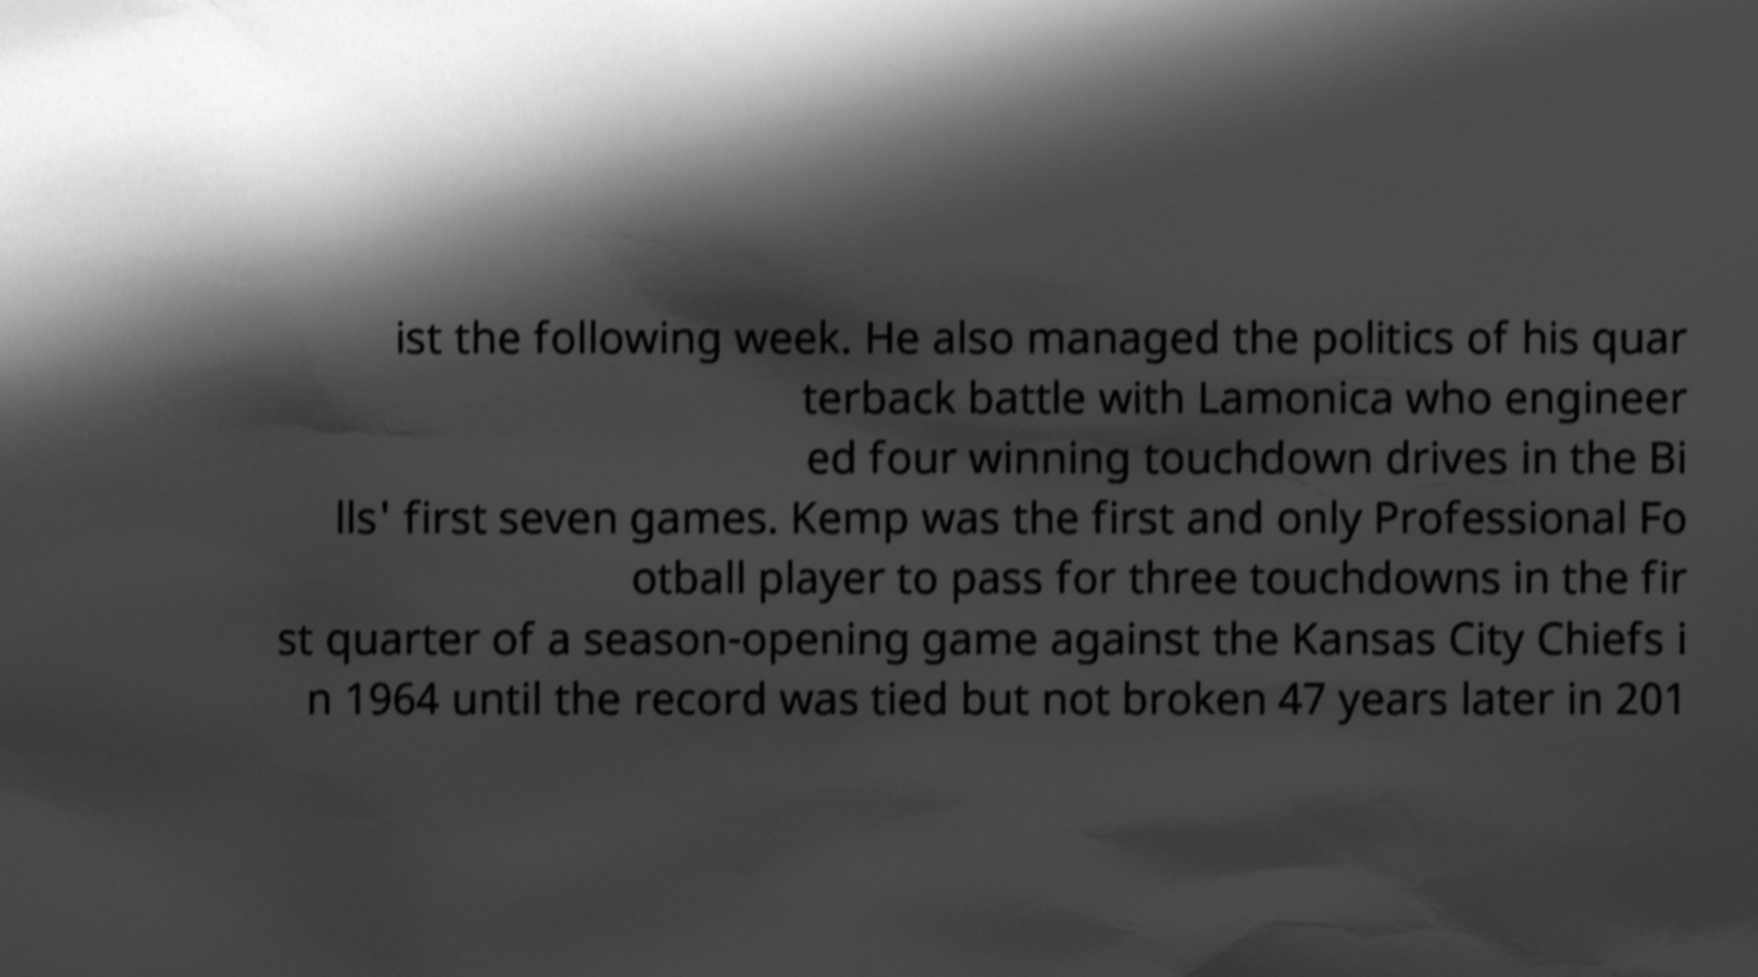Could you assist in decoding the text presented in this image and type it out clearly? ist the following week. He also managed the politics of his quar terback battle with Lamonica who engineer ed four winning touchdown drives in the Bi lls' first seven games. Kemp was the first and only Professional Fo otball player to pass for three touchdowns in the fir st quarter of a season-opening game against the Kansas City Chiefs i n 1964 until the record was tied but not broken 47 years later in 201 